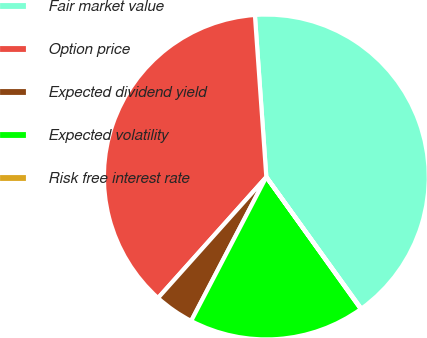Convert chart to OTSL. <chart><loc_0><loc_0><loc_500><loc_500><pie_chart><fcel>Fair market value<fcel>Option price<fcel>Expected dividend yield<fcel>Expected volatility<fcel>Risk free interest rate<nl><fcel>41.18%<fcel>37.26%<fcel>3.96%<fcel>17.55%<fcel>0.05%<nl></chart> 